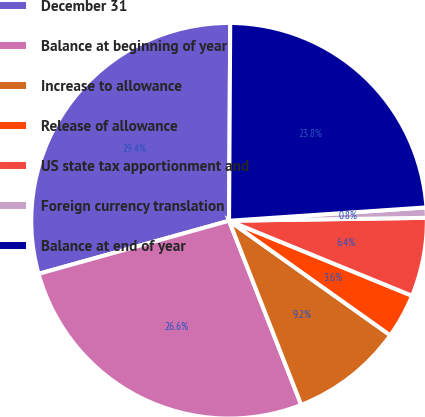Convert chart to OTSL. <chart><loc_0><loc_0><loc_500><loc_500><pie_chart><fcel>December 31<fcel>Balance at beginning of year<fcel>Increase to allowance<fcel>Release of allowance<fcel>US state tax apportionment and<fcel>Foreign currency translation<fcel>Balance at end of year<nl><fcel>29.42%<fcel>26.62%<fcel>9.22%<fcel>3.64%<fcel>6.43%<fcel>0.84%<fcel>23.83%<nl></chart> 